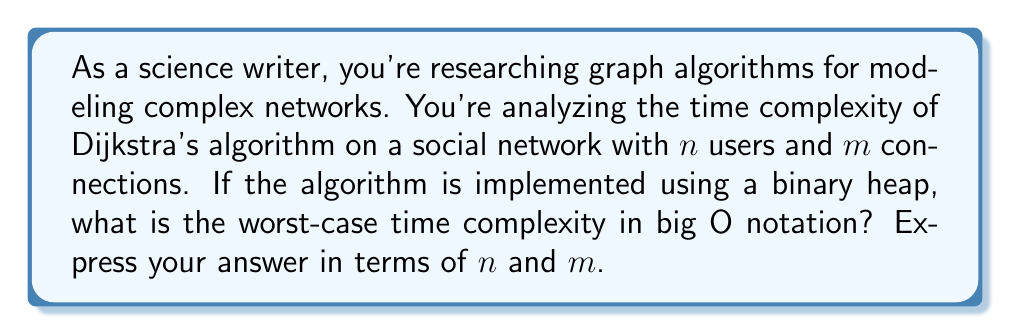Teach me how to tackle this problem. To understand the time complexity of Dijkstra's algorithm with a binary heap implementation, let's break down the process:

1. Initialization:
   - Creating a priority queue (binary heap) with $n$ vertices: $O(n)$
   - Setting initial distances: $O(n)$

2. Main loop:
   - The main loop runs $n$ times, once for each vertex.
   - In each iteration:
     a. Extract-min operation: $O(\log n)$
     b. For each adjacent edge (at most $m$ edges in total):
        - Update distance and decrease-key operation: $O(\log n)$

Let's analyze the total time complexity:

$$T(n,m) = O(n) + n \cdot O(\log n) + m \cdot O(\log n)$$

Simplifying:

$$T(n,m) = O(n + n\log n + m\log n)$$

We can further simplify this expression:

1. $n$ is always less than or equal to $n\log n$ for $n \geq 2$, so we can drop the $O(n)$ term.
2. We can factor out $\log n$:

$$T(n,m) = O((n + m)\log n)$$

This is the worst-case time complexity of Dijkstra's algorithm using a binary heap implementation.

Note: In a social network context, $m$ is often much larger than $n$, as users can have multiple connections. Therefore, this implementation is more efficient than the naive implementation with $O(n^2)$ complexity, especially for sparse graphs.
Answer: $O((n + m)\log n)$ 